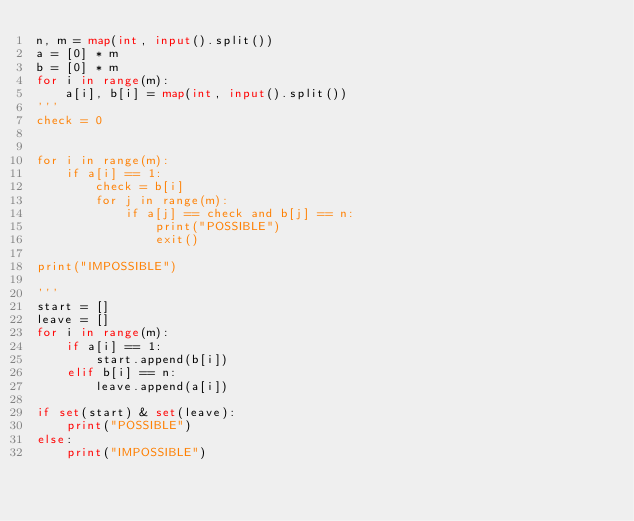Convert code to text. <code><loc_0><loc_0><loc_500><loc_500><_Python_>n, m = map(int, input().split())
a = [0] * m
b = [0] * m
for i in range(m):
    a[i], b[i] = map(int, input().split())
'''
check = 0


for i in range(m):
    if a[i] == 1:
        check = b[i]
        for j in range(m):
            if a[j] == check and b[j] == n:
                print("POSSIBLE")
                exit()

print("IMPOSSIBLE")

'''
start = []
leave = []
for i in range(m):
    if a[i] == 1:
        start.append(b[i])
    elif b[i] == n:
        leave.append(a[i])

if set(start) & set(leave):
    print("POSSIBLE")
else:
    print("IMPOSSIBLE")
</code> 